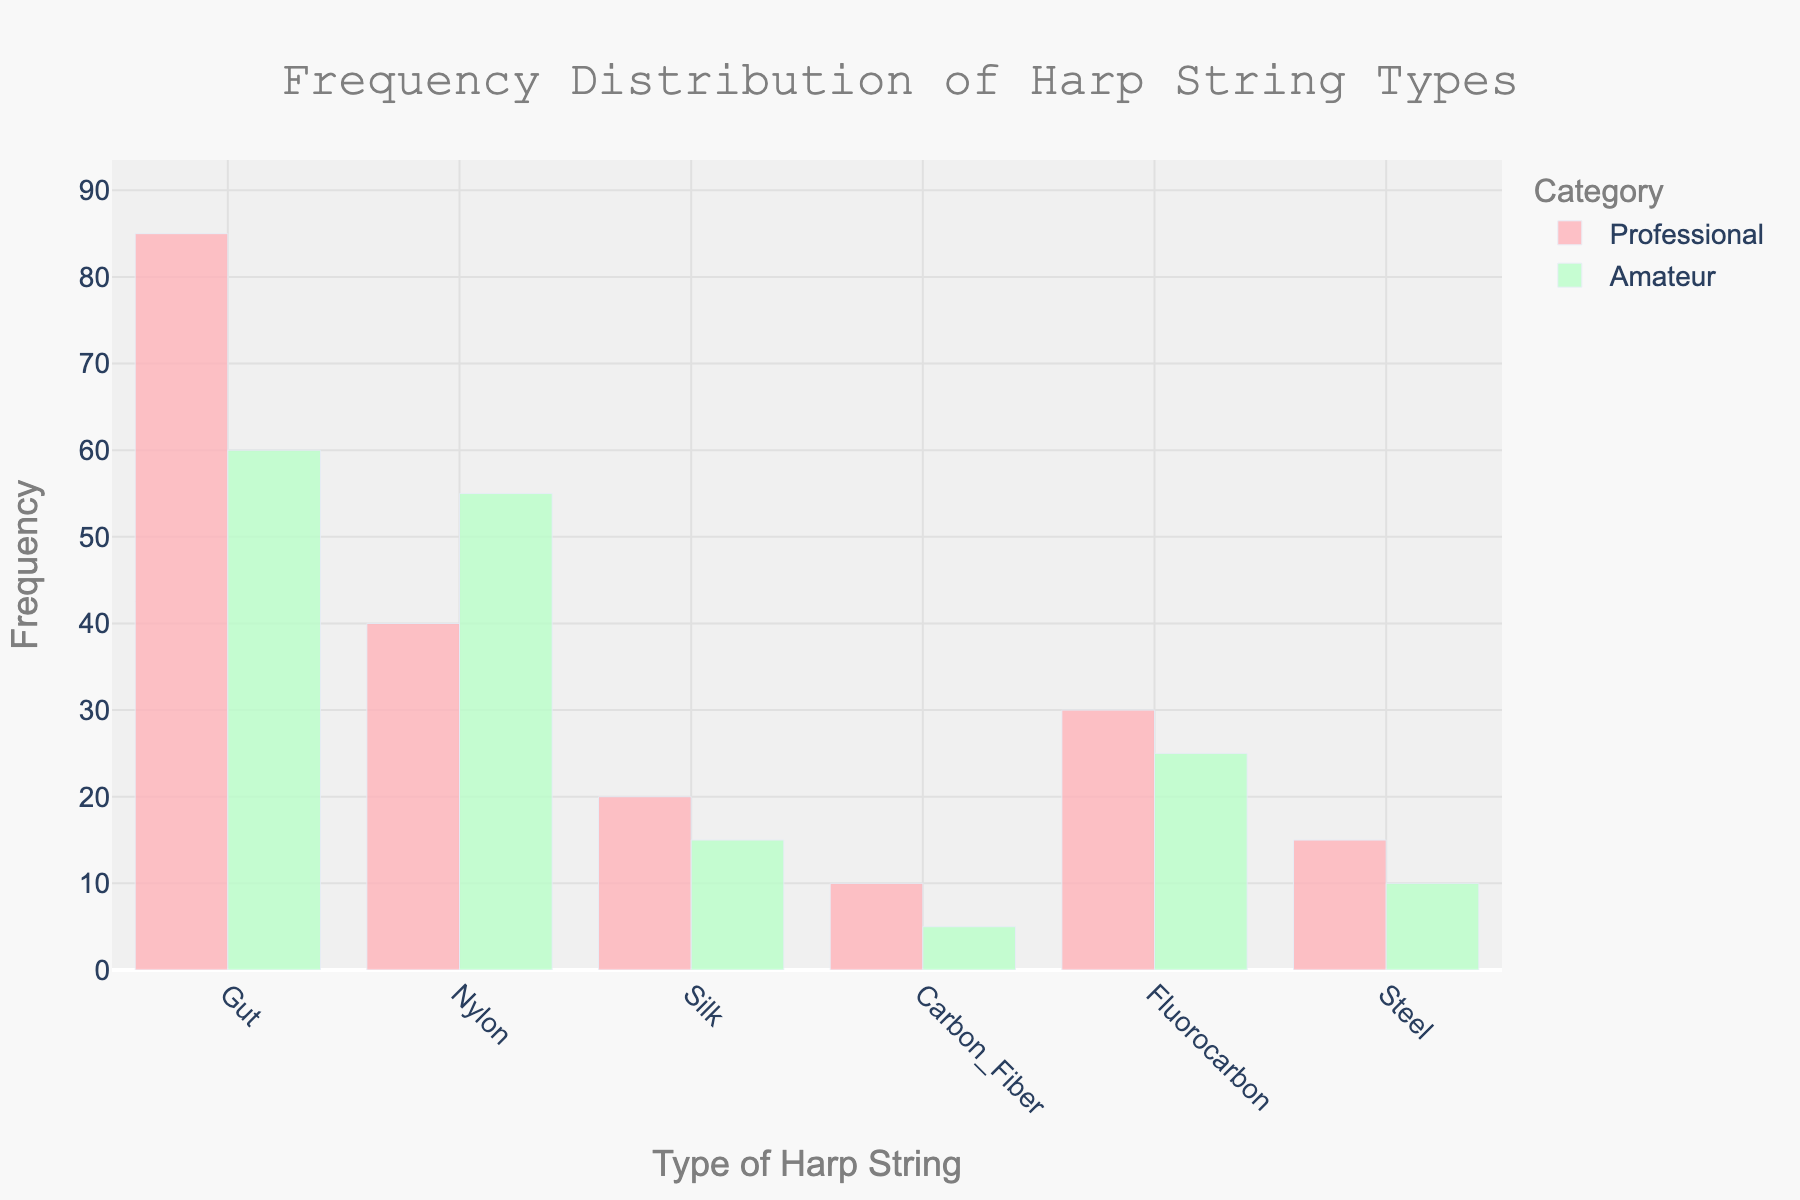What is the title of the figure? The title of the figure is positioned at the top of the plot, and it states "Frequency Distribution of Harp String Types". This can be read directly from the center-aligned text.
Answer: Frequency Distribution of Harp String Types How many types of harp strings are shown in the figure? By counting the distinct categories on the x-axis, we can see there are six types of harp strings presented: Gut, Nylon, Silk, Carbon Fiber, Fluorocarbon, and Steel.
Answer: Six What is the highest frequency of harp string usage by professional harpists? By examining the bars representing professional harpists, the highest bar corresponds to Gut with a frequency value of 85.
Answer: 85 Which type of harp string is used more frequently by amateur harpists than professional harpists? By comparing the heights of bars for each string type between professional and amateur categories, Nylon is used more frequently by amateur harpists (55) than professional harpists (40).
Answer: Nylon What is the least used type of harp string by amateur harpists? The smallest bar in the amateur category corresponds to Carbon Fiber, which has a frequency of 5.
Answer: Carbon Fiber What is the combined frequency of Fluorocarbon strings used by both professional and amateur harpists? Summing the frequencies of Fluorocarbon strings for professionals (30) and amateurs (25) gives a total frequency of 55.
Answer: 55 For which type of harp string is the frequency of usage equal between professional and amateur harpists? Observing the heights of the bars, none of the string types have equal frequencies between the two categories.
Answer: None By how much does the frequency of Gut strings used by professional harpists exceed those used by amateur harpists? The frequency of Gut strings used by professionals (85) minus the frequency used by amateurs (60) gives a difference of 25.
Answer: 25 On the y-axis, what is the range of frequencies covered in the plot? The y-axis scale ranges from 0 to a maximum, which is set to slightly above the highest value observed, here around 95 (110% of the highest frequency, 85).
Answer: 0 to ~95 